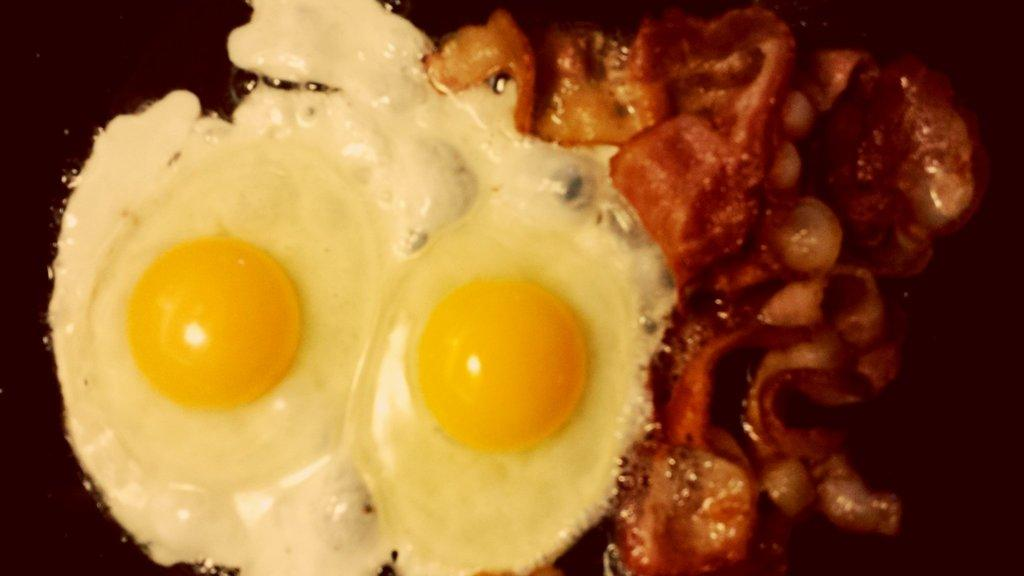What type of food can be seen in the picture? There is an egg and meat in the picture in the picture. Can you describe the egg in the picture? The egg is the main subject in the picture. How many icicles are hanging from the egg in the picture? There are no icicles present in the image; it features an egg and meat. What type of coast can be seen in the background of the picture? There is no coast visible in the image, as it only contains an egg and meat. 